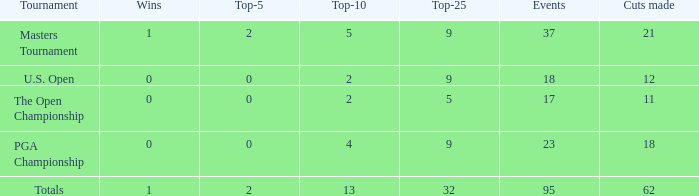What is the quantity of victories in the top 10 that exceed 13? None. 